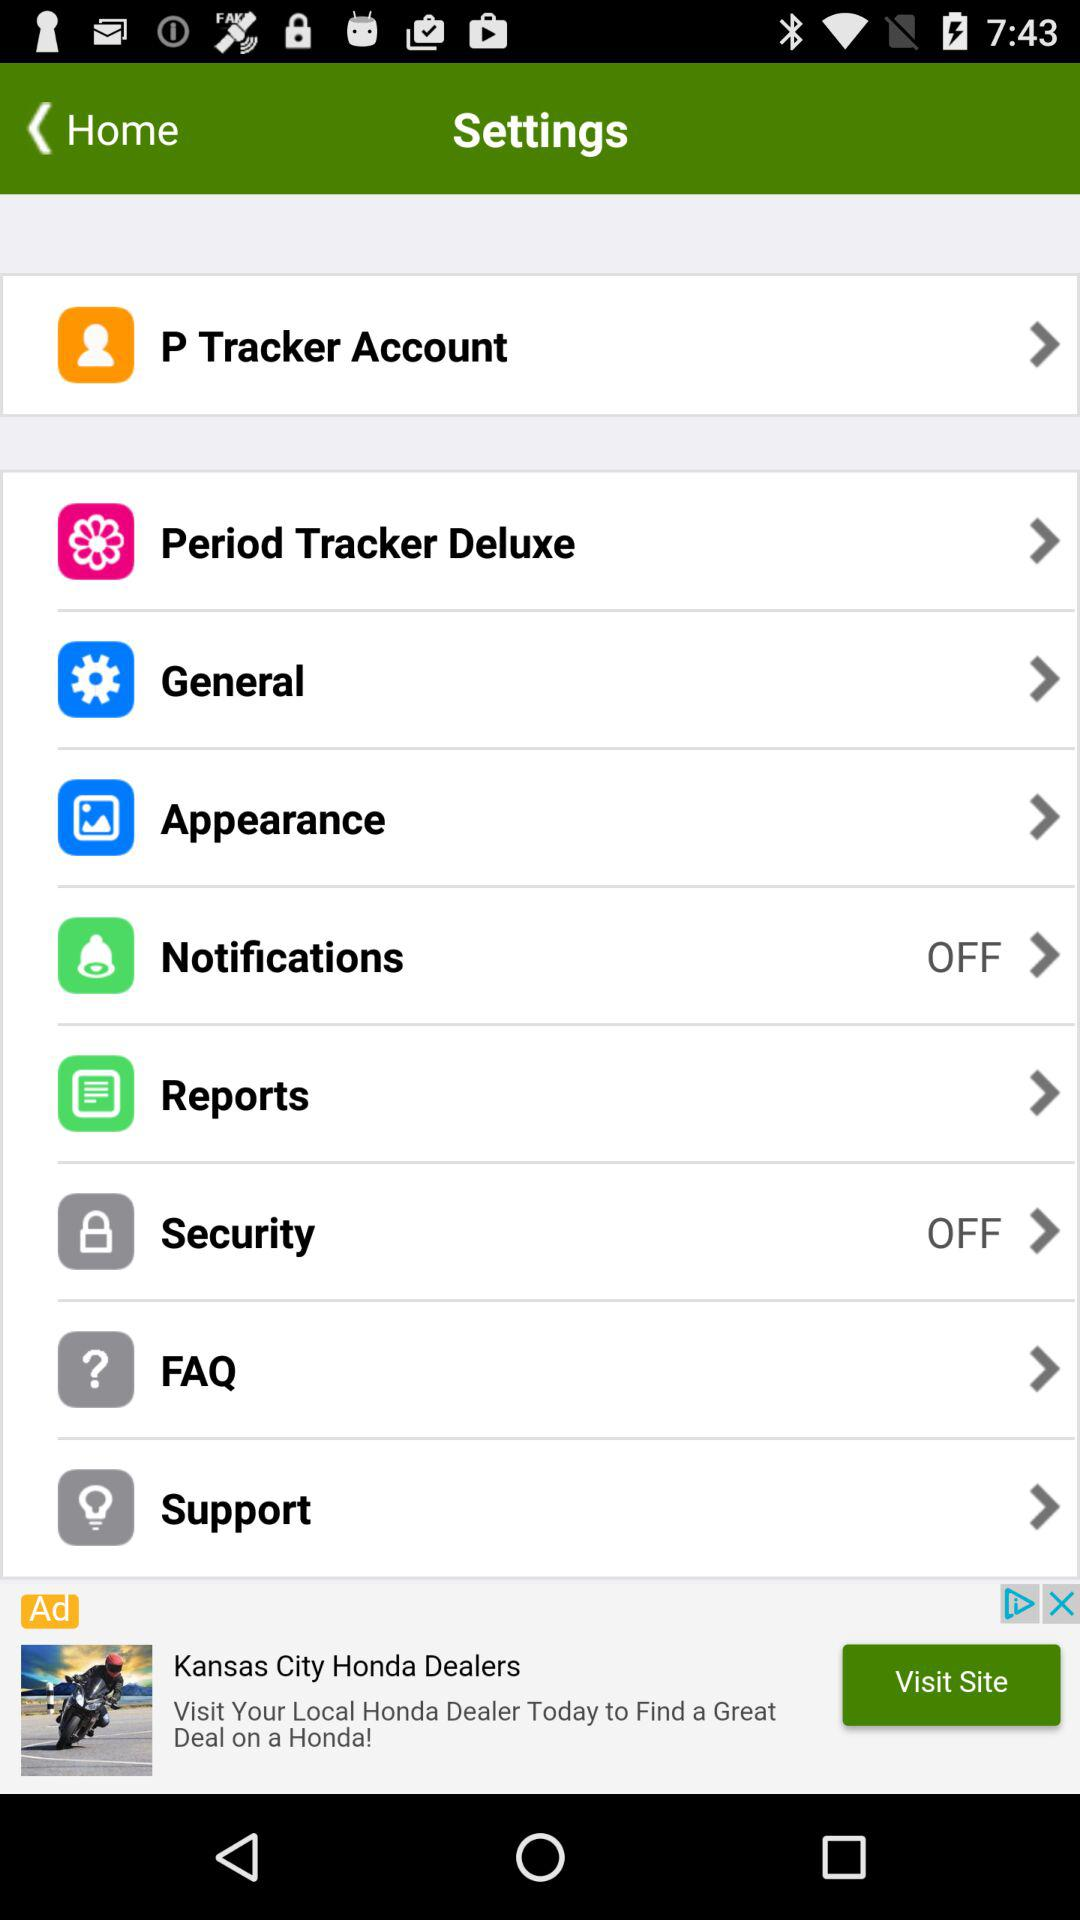What is the status of "Security"? "Security" is turned off. 